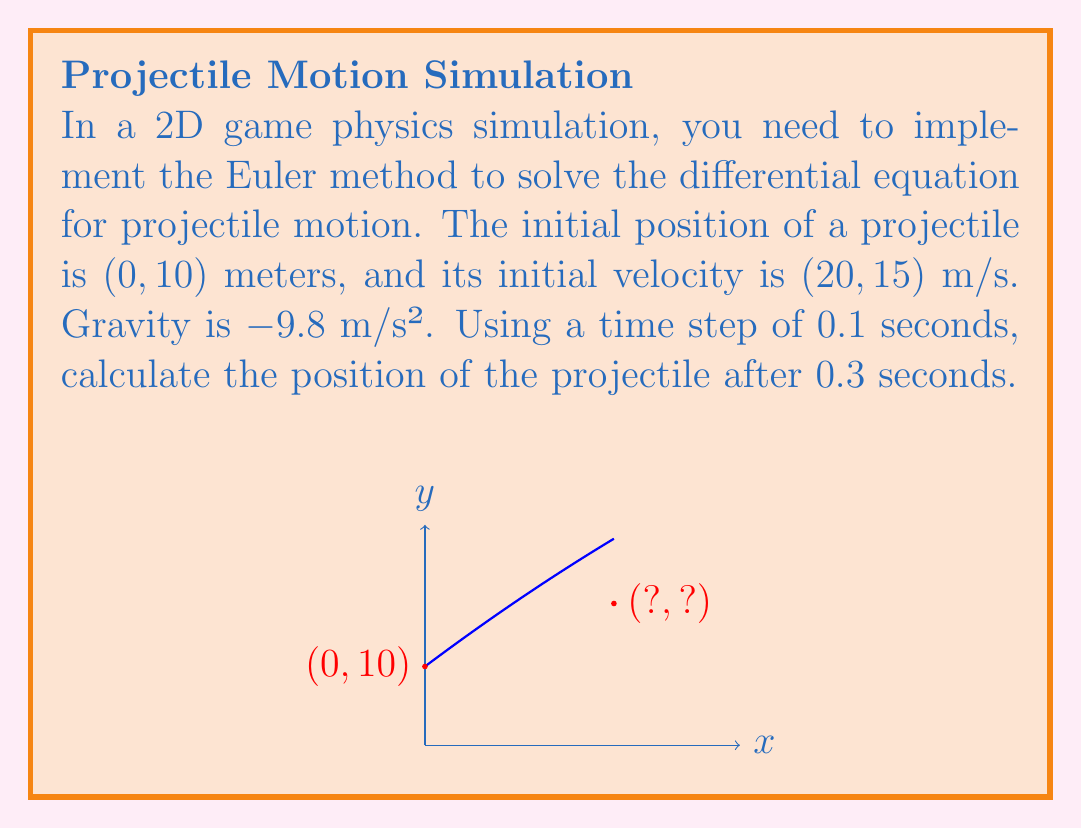What is the answer to this math problem? To solve this problem using the Euler method, we'll follow these steps:

1) The differential equations for projectile motion are:

   $$\frac{dx}{dt} = v_x$$
   $$\frac{dy}{dt} = v_y$$
   $$\frac{dv_x}{dt} = 0$$
   $$\frac{dv_y}{dt} = g$$

   Where $g = -9.8$ m/s².

2) The Euler method updates the position and velocity as follows:

   $$x_{n+1} = x_n + v_x \Delta t$$
   $$y_{n+1} = y_n + v_y \Delta t$$
   $$v_{x,n+1} = v_{x,n}$$
   $$v_{y,n+1} = v_{y,n} + g \Delta t$$

3) Initial conditions:
   $x_0 = 0$, $y_0 = 10$, $v_{x,0} = 20$, $v_{y,0} = 15$, $\Delta t = 0.1$

4) We need to perform 3 iterations ($t = 0.3$ s):

   Iteration 1 ($t = 0.1$ s):
   $$x_1 = 0 + 20 * 0.1 = 2$$
   $$y_1 = 10 + 15 * 0.1 = 11.5$$
   $$v_{x,1} = 20$$
   $$v_{y,1} = 15 + (-9.8) * 0.1 = 14.02$$

   Iteration 2 ($t = 0.2$ s):
   $$x_2 = 2 + 20 * 0.1 = 4$$
   $$y_2 = 11.5 + 14.02 * 0.1 = 12.902$$
   $$v_{x,2} = 20$$
   $$v_{y,2} = 14.02 + (-9.8) * 0.1 = 13.04$$

   Iteration 3 ($t = 0.3$ s):
   $$x_3 = 4 + 20 * 0.1 = 6$$
   $$y_3 = 12.902 + 13.04 * 0.1 = 14.206$$

5) Therefore, the position after 0.3 seconds is approximately (6, 14.206) meters.
Answer: (6, 14.206) m 